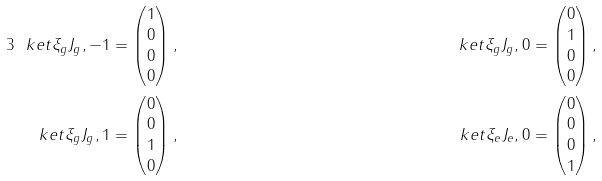<formula> <loc_0><loc_0><loc_500><loc_500>{ 3 } \ k e t { \xi _ { g } J _ { g } , - 1 } & = \begin{pmatrix} 1 \\ 0 \\ 0 \\ 0 \end{pmatrix} , & \quad \ k e t { \xi _ { g } J _ { g } , 0 } & = \begin{pmatrix} 0 \\ 1 \\ 0 \\ 0 \end{pmatrix} , \\ \ k e t { \xi _ { g } J _ { g } , 1 } & = \begin{pmatrix} 0 \\ 0 \\ 1 \\ 0 \end{pmatrix} , & \quad \ k e t { \xi _ { e } J _ { e } , 0 } & = \begin{pmatrix} 0 \\ 0 \\ 0 \\ 1 \end{pmatrix} ,</formula> 